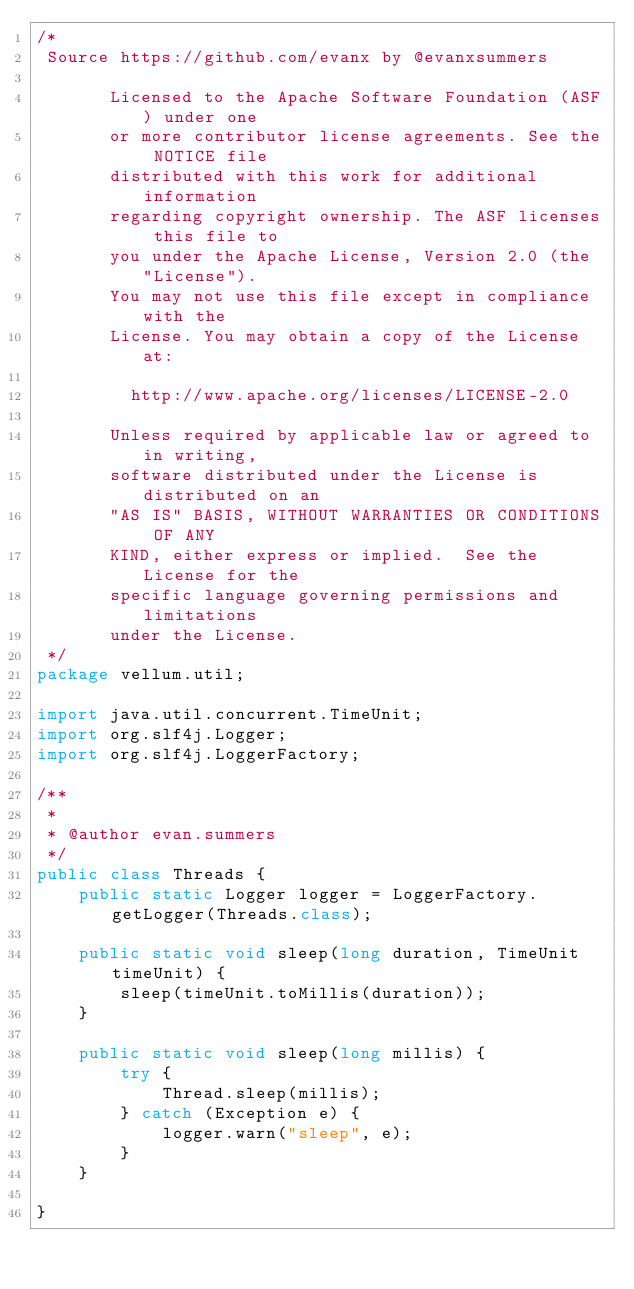<code> <loc_0><loc_0><loc_500><loc_500><_Java_>/*
 Source https://github.com/evanx by @evanxsummers

       Licensed to the Apache Software Foundation (ASF) under one
       or more contributor license agreements. See the NOTICE file
       distributed with this work for additional information
       regarding copyright ownership. The ASF licenses this file to
       you under the Apache License, Version 2.0 (the "License").
       You may not use this file except in compliance with the
       License. You may obtain a copy of the License at:

         http://www.apache.org/licenses/LICENSE-2.0

       Unless required by applicable law or agreed to in writing,
       software distributed under the License is distributed on an
       "AS IS" BASIS, WITHOUT WARRANTIES OR CONDITIONS OF ANY
       KIND, either express or implied.  See the License for the
       specific language governing permissions and limitations
       under the License.  
 */
package vellum.util;

import java.util.concurrent.TimeUnit;
import org.slf4j.Logger;
import org.slf4j.LoggerFactory;

/**
 *
 * @author evan.summers
 */
public class Threads {
    public static Logger logger = LoggerFactory.getLogger(Threads.class);

    public static void sleep(long duration, TimeUnit timeUnit) {
        sleep(timeUnit.toMillis(duration));
    }
    
    public static void sleep(long millis) {
        try {
            Thread.sleep(millis);
        } catch (Exception e) {
            logger.warn("sleep", e);
        }
    }
    
}
</code> 